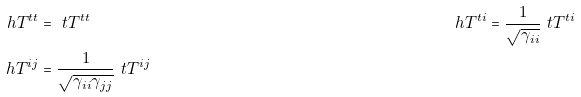Convert formula to latex. <formula><loc_0><loc_0><loc_500><loc_500>\ h { T } ^ { t t } & = \ t { T } ^ { t t } & \ h { T } ^ { t i } & = \frac { 1 } { \sqrt { \gamma _ { i i } } } \ t { T } ^ { t i } \\ \ h { T } ^ { i j } & = \frac { 1 } { \sqrt { \gamma _ { i i } \gamma _ { j j } } } \ t { T } ^ { i j }</formula> 